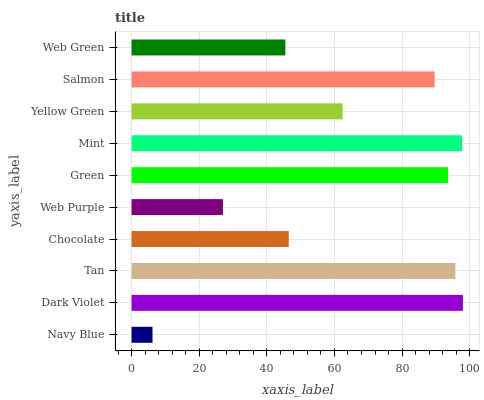Is Navy Blue the minimum?
Answer yes or no. Yes. Is Dark Violet the maximum?
Answer yes or no. Yes. Is Tan the minimum?
Answer yes or no. No. Is Tan the maximum?
Answer yes or no. No. Is Dark Violet greater than Tan?
Answer yes or no. Yes. Is Tan less than Dark Violet?
Answer yes or no. Yes. Is Tan greater than Dark Violet?
Answer yes or no. No. Is Dark Violet less than Tan?
Answer yes or no. No. Is Salmon the high median?
Answer yes or no. Yes. Is Yellow Green the low median?
Answer yes or no. Yes. Is Yellow Green the high median?
Answer yes or no. No. Is Dark Violet the low median?
Answer yes or no. No. 